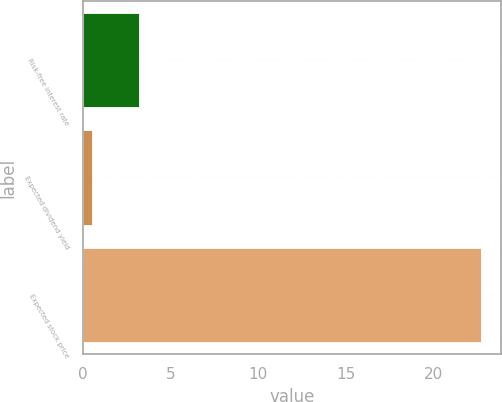Convert chart to OTSL. <chart><loc_0><loc_0><loc_500><loc_500><bar_chart><fcel>Risk-free interest rate<fcel>Expected dividend yield<fcel>Expected stock price<nl><fcel>3.2<fcel>0.5<fcel>22.7<nl></chart> 